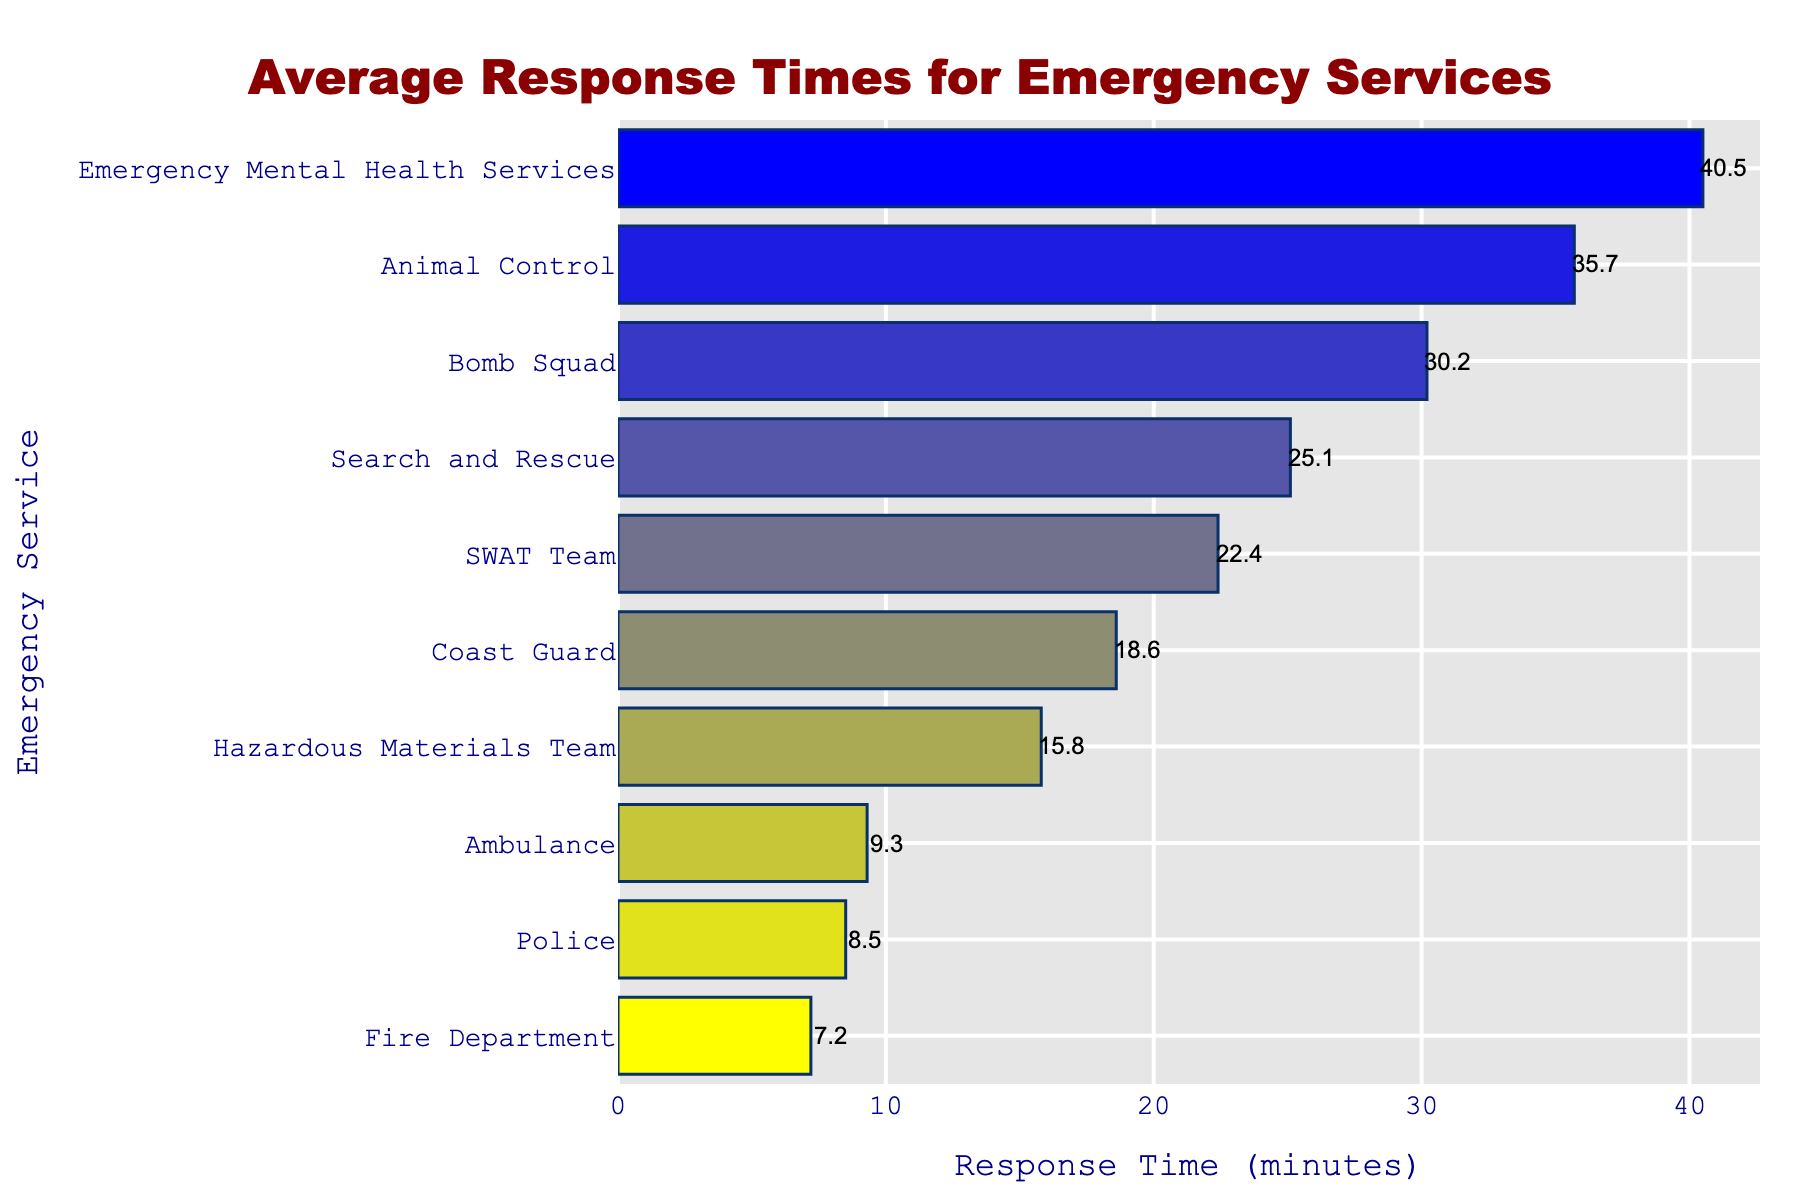What's the fastest average response time and which emergency service does it belong to? The lowest bar on the chart indicates the fastest response time. According to the data, the Fire Department has the shortest response time of 7.2 minutes.
Answer: 7.2 minutes, Fire Department Which emergency service has the longest average response time? By looking at the bar that extends the farthest to the right, we can see that Emergency Mental Health Services has the longest response time of 40.5 minutes.
Answer: Emergency Mental Health Services Which emergency service has a faster average response time: Police or Ambulance? Compare the lengths of the bars for Police and Ambulance. The Police have a response time of 8.5 minutes, which is shorter than the Ambulance's 9.3 minutes.
Answer: Police What is the difference in average response time between the SWAT Team and the Bomb Squad? Subtract the average response time of the Bomb Squad (30.2 minutes) from the SWAT Team (22.4 minutes) to find the difference, 30.2 - 22.4 = 7.8 minutes.
Answer: 7.8 minutes What's the combined average response time of Animal Control and Search and Rescue? Add the average response times of Animal Control (35.7 minutes) and Search and Rescue (25.1 minutes), 35.7 + 25.1 = 60.8 minutes.
Answer: 60.8 minutes Which emergency service has a response time closest to the median response time of all services? Arrange all the response times in ascending order and find the median. The median of the ordered list (7.2, 8.5, 9.3, 15.8, 18.6, 22.4, 25.1, 30.2, 35.7, 40.5) is the average of the 5th and 6th values: (18.6 + 22.4)/2 = 20.5 minutes. The closest service is SWAT Team with 22.4 minutes.
Answer: SWAT Team Between the Coast Guard and the Hazardous Materials Team, which has a lower response time and by how much? Compare the bars and subtract their response times: Coast Guard (18.6 minutes) and Hazardous Materials Team (15.8 minutes), 18.6 - 15.8 = 2.8 minutes.
Answer: Hazardous Materials Team, 2.8 minutes How much greater is the response time of Animal Control compared to the Fire Department? Subtract Fire Department's response time from Animal Control's: 35.7 - 7.2 = 28.5 minutes.
Answer: 28.5 minutes What is the average response time of all emergency services combined? Sum all the average response times and divide by the number of services: (8.5 + 7.2 + 9.3 + 18.6 + 22.4 + 15.8 + 25.1 + 35.7 + 30.2 + 40.5) / 10 = 213.3 / 10 = 21.33 minutes.
Answer: 21.33 minutes 